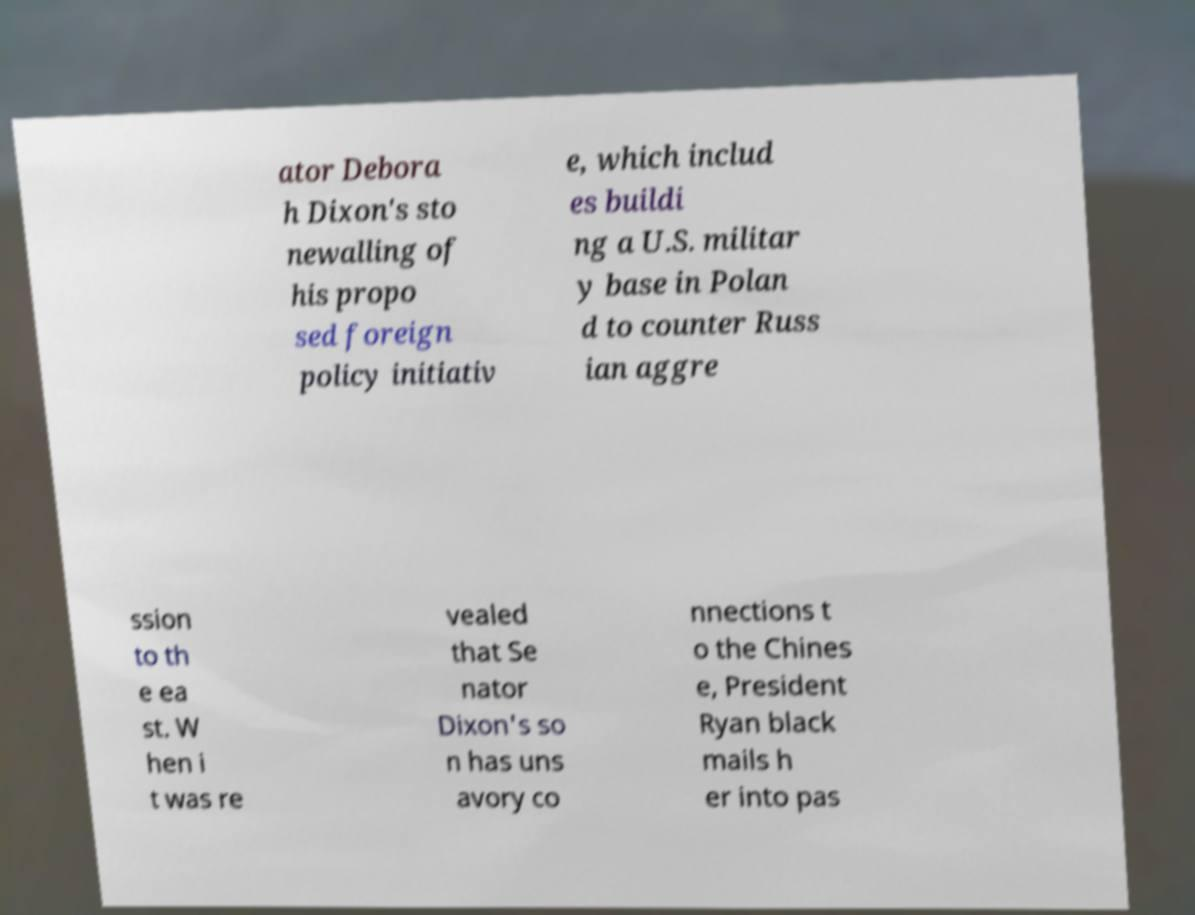Can you read and provide the text displayed in the image?This photo seems to have some interesting text. Can you extract and type it out for me? ator Debora h Dixon's sto newalling of his propo sed foreign policy initiativ e, which includ es buildi ng a U.S. militar y base in Polan d to counter Russ ian aggre ssion to th e ea st. W hen i t was re vealed that Se nator Dixon's so n has uns avory co nnections t o the Chines e, President Ryan black mails h er into pas 